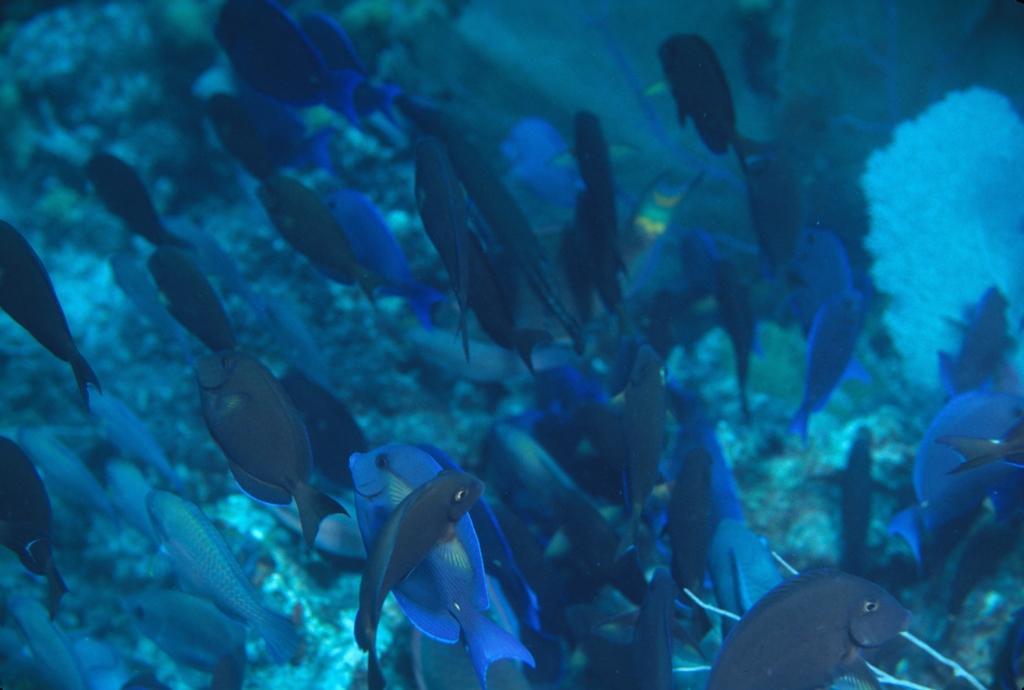In one or two sentences, can you explain what this image depicts? As we can see in the image there is water. In water there are fishes. 